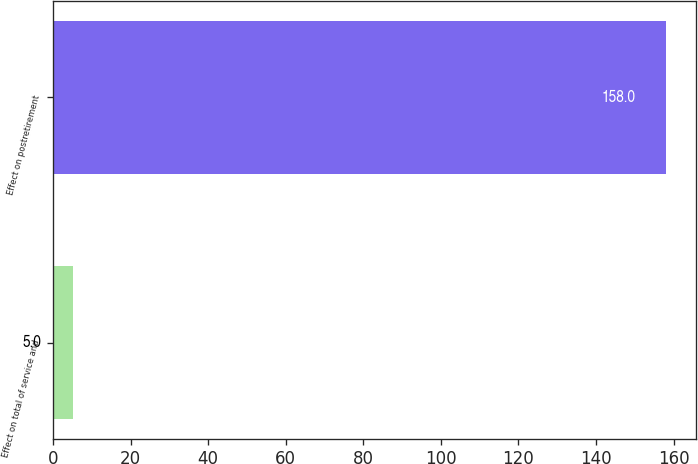Convert chart. <chart><loc_0><loc_0><loc_500><loc_500><bar_chart><fcel>Effect on total of service and<fcel>Effect on postretirement<nl><fcel>5<fcel>158<nl></chart> 